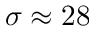Convert formula to latex. <formula><loc_0><loc_0><loc_500><loc_500>\sigma \approx 2 8</formula> 